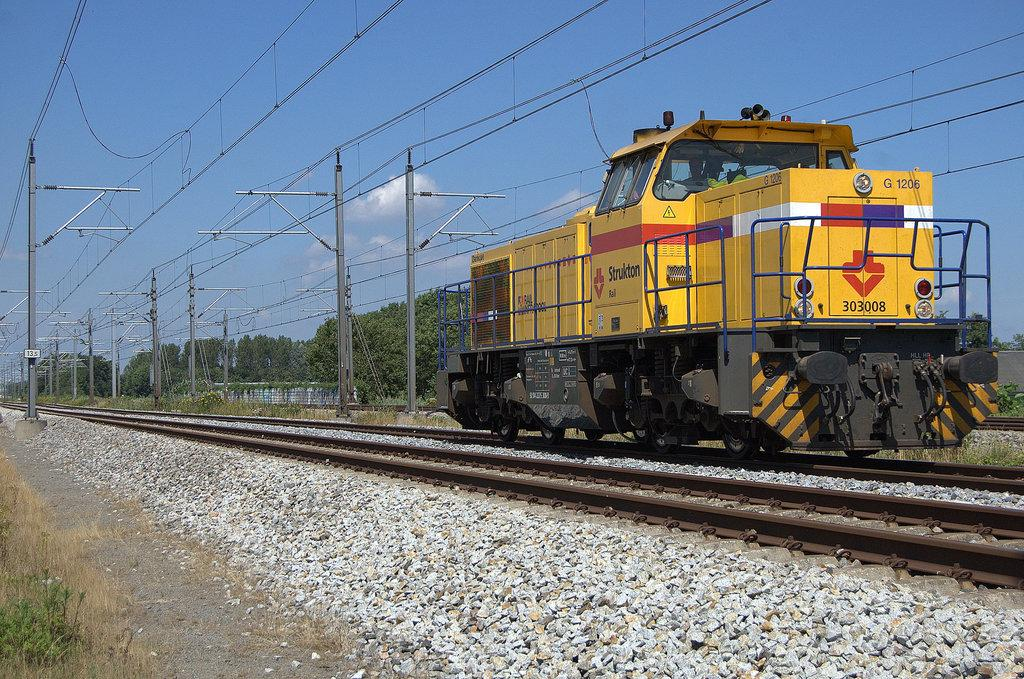What is the main subject of the image? The main subject of the image is a train. What can be seen beneath the train? There are rail tracks and stones on the ground visible in the image. What type of vegetation is present in the image? There are trees and plants in the image. What structures are present in the image? There is a wall, poles, and a board with text in the image. What is visible in the sky? The sky is visible in the image, and there are clouds present. What type of string is being used to hold the train in the image? There is no string present in the image; the train is not being held by any string. How many cubs can be seen playing near the train in the image? There are no cubs present in the image; the focus is on the train and its surroundings. 